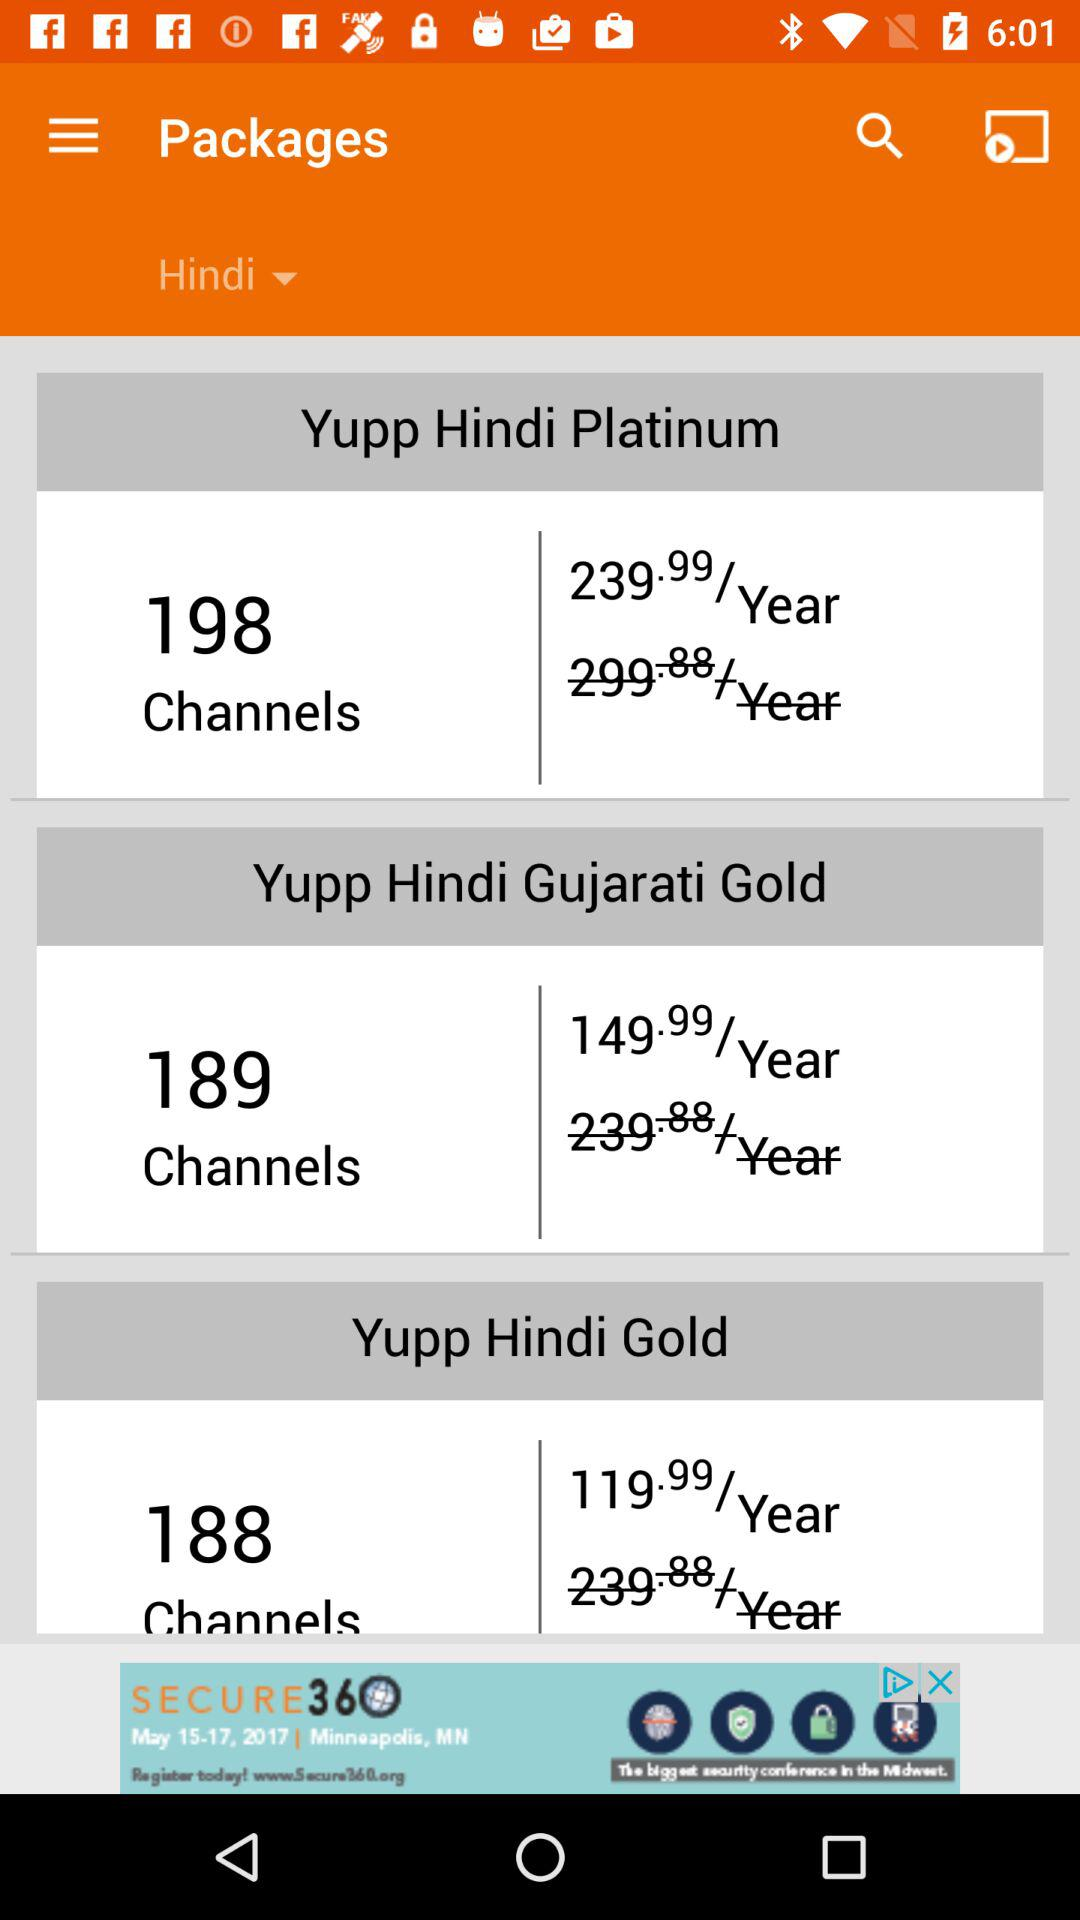What does the "Yupp Hindi Platinum" package include? The "Yupp Hindi Platinum" package includes 198 channels for 239.99 per year. 